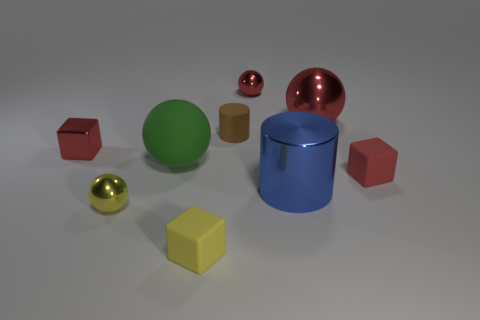The metallic object that is both behind the large green ball and on the left side of the small yellow cube is what color?
Your response must be concise. Red. There is a tiny red object that is in front of the red shiny block; is it the same shape as the matte thing that is behind the large rubber sphere?
Offer a very short reply. No. There is a tiny thing that is on the right side of the big red sphere; what is its material?
Your answer should be very brief. Rubber. There is another cube that is the same color as the metal block; what is its size?
Your response must be concise. Small. How many things are large things that are right of the brown object or matte objects?
Ensure brevity in your answer.  6. Are there an equal number of big blue metal cylinders that are left of the large matte object and purple matte blocks?
Keep it short and to the point. Yes. Does the blue cylinder have the same size as the brown thing?
Offer a very short reply. No. There is a metallic cube that is the same size as the brown rubber cylinder; what color is it?
Your answer should be very brief. Red. There is a yellow metal object; does it have the same size as the blue shiny cylinder that is in front of the big red metal sphere?
Provide a succinct answer. No. How many big spheres have the same color as the tiny metallic cube?
Provide a short and direct response. 1. 